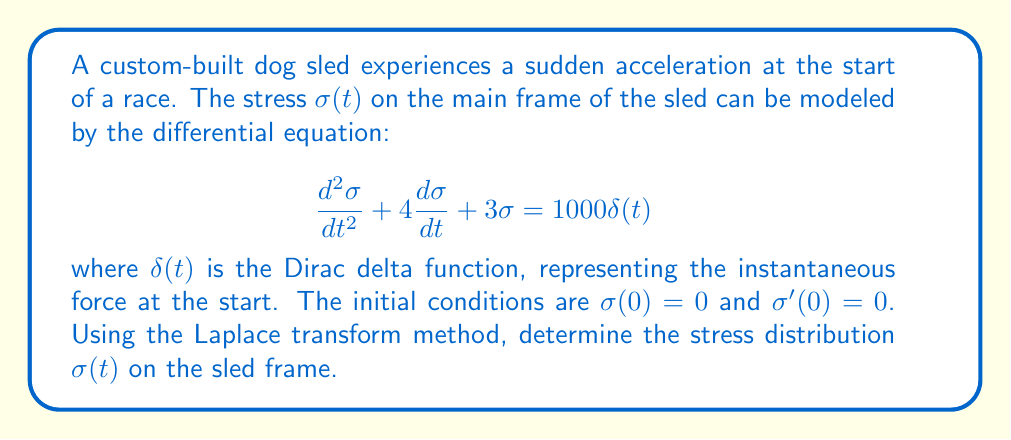What is the answer to this math problem? Let's solve this problem step by step using the Laplace transform method:

1) First, we take the Laplace transform of both sides of the differential equation:

   $$\mathcal{L}\{{\frac{d^2\sigma}{dt^2} + 4\frac{d\sigma}{dt} + 3\sigma}\} = \mathcal{L}\{1000\delta(t)\}$$

2) Using the properties of Laplace transforms:

   $$s^2\Sigma(s) - s\sigma(0) - \sigma'(0) + 4[s\Sigma(s) - \sigma(0)] + 3\Sigma(s) = 1000$$

   where $\Sigma(s)$ is the Laplace transform of $\sigma(t)$.

3) Substituting the initial conditions $\sigma(0) = 0$ and $\sigma'(0) = 0$:

   $$s^2\Sigma(s) + 4s\Sigma(s) + 3\Sigma(s) = 1000$$

4) Factoring out $\Sigma(s)$:

   $$\Sigma(s)(s^2 + 4s + 3) = 1000$$

5) Solving for $\Sigma(s)$:

   $$\Sigma(s) = \frac{1000}{s^2 + 4s + 3} = \frac{1000}{(s+1)(s+3)}$$

6) Using partial fraction decomposition:

   $$\Sigma(s) = \frac{A}{s+1} + \frac{B}{s+3}$$

   where $A$ and $B$ are constants to be determined.

7) Finding $A$ and $B$:

   $$1000 = A(s+3) + B(s+1)$$
   
   When $s = -1$: $1000 = 2A$, so $A = 500$
   When $s = -3$: $1000 = -2B$, so $B = -500$

8) Therefore:

   $$\Sigma(s) = \frac{500}{s+1} - \frac{500}{s+3}$$

9) Taking the inverse Laplace transform:

   $$\sigma(t) = \mathcal{L}^{-1}\{\Sigma(s)\} = 500e^{-t} - 500e^{-3t}$$

This is the stress distribution on the sled frame as a function of time.
Answer: $$\sigma(t) = 500e^{-t} - 500e^{-3t}$$ 